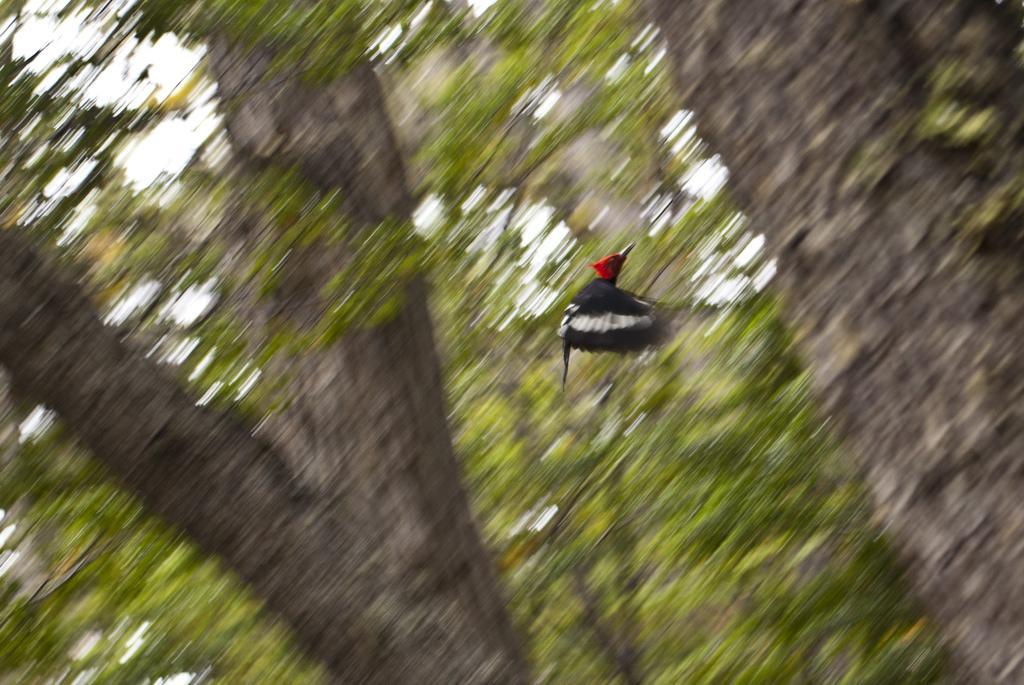Can you describe this image briefly? In this picture there is a bird in the center of the image and there are trees in the background area of the image. 